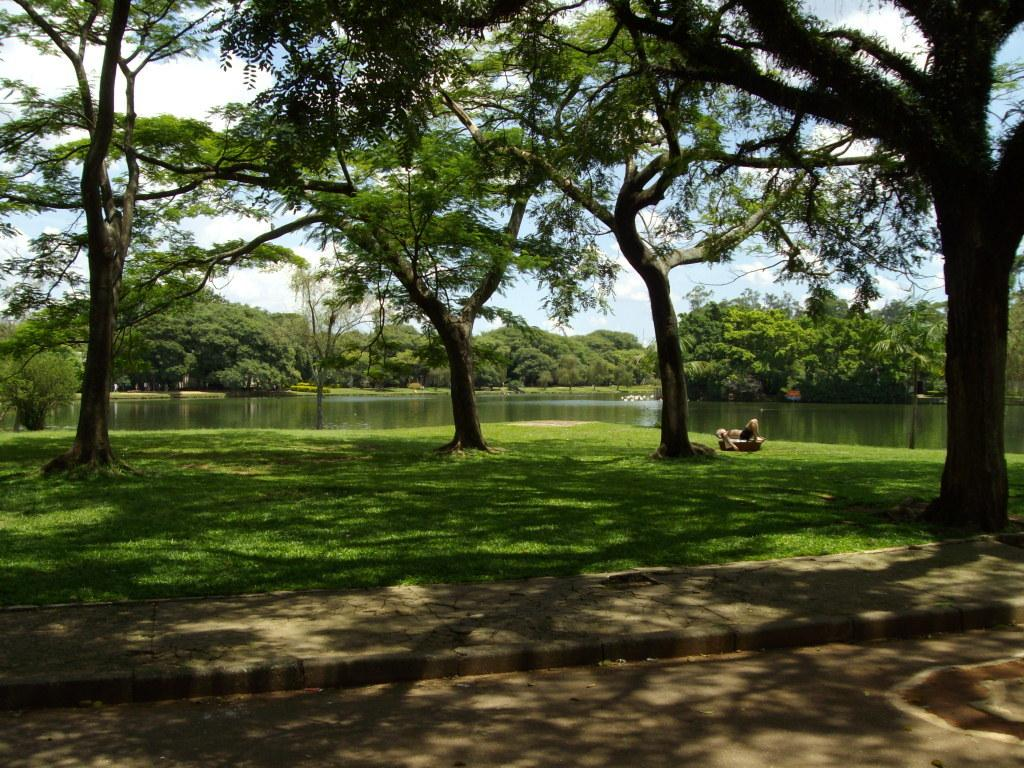What type of vegetation is present in the image? There is grass and trees in the image. What body of water can be seen in the image? There is a lake in the middle of the image. What is visible in the sky in the background of the image? There are clouds in the sky in the background of the image. What direction are the songs coming from in the image? There are no songs or any indication of sound in the image. 